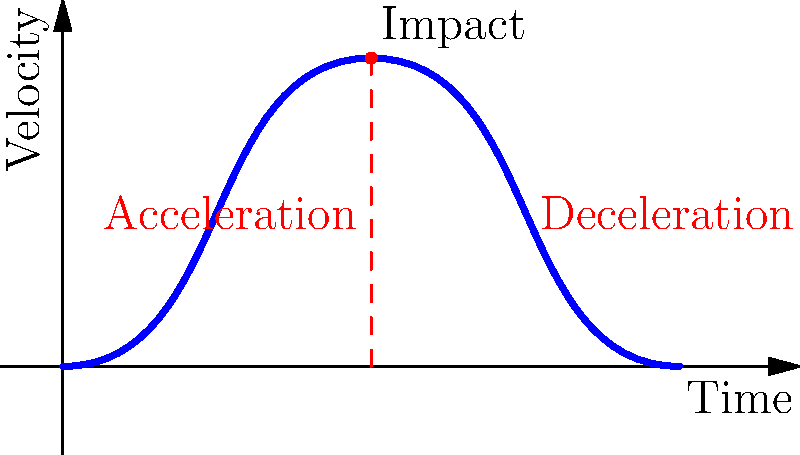In a fighting game with realistic ragdoll physics, you're implementing a feature where characters react dynamically to impacts. Given the velocity-time graph of a character during a collision, what key aspect of ragdoll physics does the steep vertical line at the point of impact represent, and how does it contribute to creating a more immersive gaming experience? To understand the ragdoll physics in this scenario, let's break down the graph and its implications:

1. The blue curve represents the velocity of the character over time.

2. The steep red dashed line at the point of impact represents a sudden change in velocity, which is crucial for realistic ragdoll physics.

3. This abrupt change in velocity is actually the acceleration (or deceleration) of the character upon impact. In physics, acceleration is defined as the rate of change of velocity with respect to time ($$a = \frac{dv}{dt}$$).

4. The steepness of this line indicates a very rapid change in velocity, which is characteristic of collisions in fighting games.

5. This sudden acceleration is key to simulating realistic ragdoll physics because:
   a) It mimics the abrupt forces experienced during a real impact.
   b) It allows for dynamic and unpredictable character reactions.
   c) It creates a visual representation of the impact's intensity.

6. In ragdoll physics, this acceleration is applied to different parts of the character's body, causing them to react independently and realistically.

7. The subsequent curve after the impact shows the character's deceleration, which adds to the realism by simulating the dissipation of energy after the collision.

8. This implementation creates a more immersive gaming experience by:
   a) Providing visual feedback on the strength and direction of impacts.
   b) Creating unique and dynamic character reactions to each hit.
   c) Enhancing the perceived physicality of the game world.

The key aspect represented by the steep line is the sudden acceleration at the point of impact, which is crucial for simulating realistic collision responses in ragdoll physics.
Answer: Sudden acceleration (impulse) 